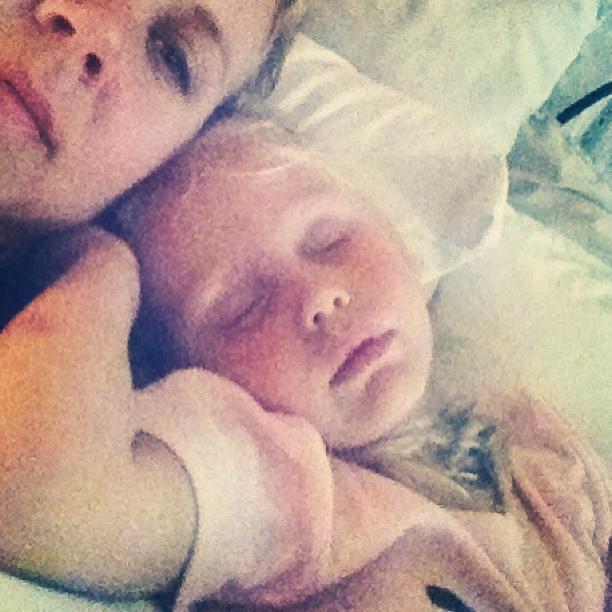How many people are in this picture?
Give a very brief answer. 2. How many people are there?
Give a very brief answer. 2. How many bananas are there?
Give a very brief answer. 0. 